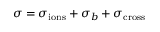<formula> <loc_0><loc_0><loc_500><loc_500>\sigma = \sigma _ { i o n s } + \sigma _ { b } + \sigma _ { c r o s s }</formula> 